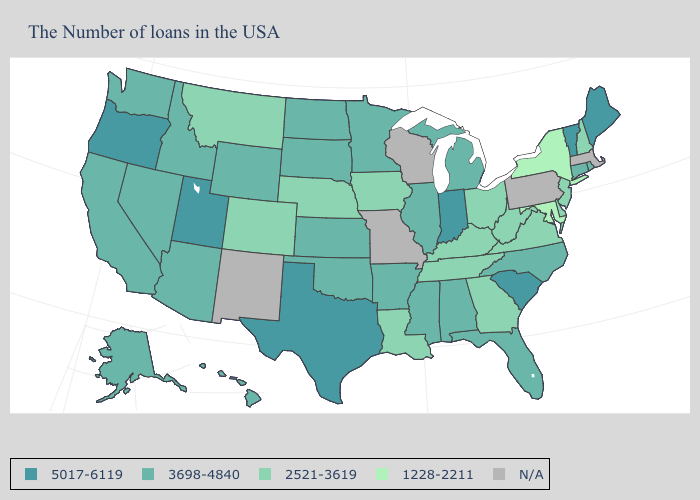Which states have the highest value in the USA?
Give a very brief answer. Maine, Vermont, South Carolina, Indiana, Texas, Utah, Oregon. What is the lowest value in the Northeast?
Give a very brief answer. 1228-2211. Name the states that have a value in the range 1228-2211?
Give a very brief answer. New York, Maryland. Does the first symbol in the legend represent the smallest category?
Write a very short answer. No. What is the value of Vermont?
Give a very brief answer. 5017-6119. What is the value of Minnesota?
Short answer required. 3698-4840. What is the highest value in the South ?
Be succinct. 5017-6119. What is the highest value in the Northeast ?
Keep it brief. 5017-6119. Among the states that border New Jersey , does New York have the lowest value?
Write a very short answer. Yes. Which states have the lowest value in the Northeast?
Give a very brief answer. New York. Name the states that have a value in the range 5017-6119?
Be succinct. Maine, Vermont, South Carolina, Indiana, Texas, Utah, Oregon. What is the value of Montana?
Be succinct. 2521-3619. Does Utah have the lowest value in the USA?
Keep it brief. No. 